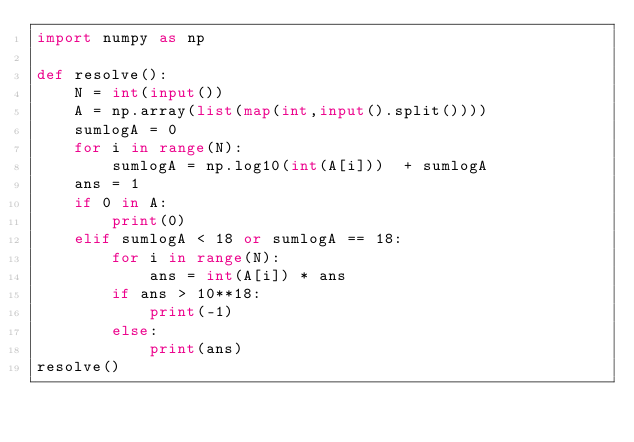Convert code to text. <code><loc_0><loc_0><loc_500><loc_500><_Python_>import numpy as np

def resolve():
    N = int(input())
    A = np.array(list(map(int,input().split())))
    sumlogA = 0
    for i in range(N):
        sumlogA = np.log10(int(A[i]))  + sumlogA
    ans = 1
    if 0 in A:
        print(0)
    elif sumlogA < 18 or sumlogA == 18:
        for i in range(N):
            ans = int(A[i]) * ans
        if ans > 10**18:
            print(-1)
        else:
            print(ans)
resolve()</code> 